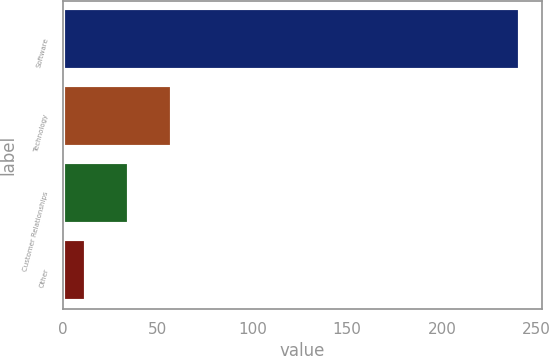Convert chart. <chart><loc_0><loc_0><loc_500><loc_500><bar_chart><fcel>Software<fcel>Technology<fcel>Customer Relationships<fcel>Other<nl><fcel>241<fcel>57.8<fcel>34.9<fcel>12<nl></chart> 